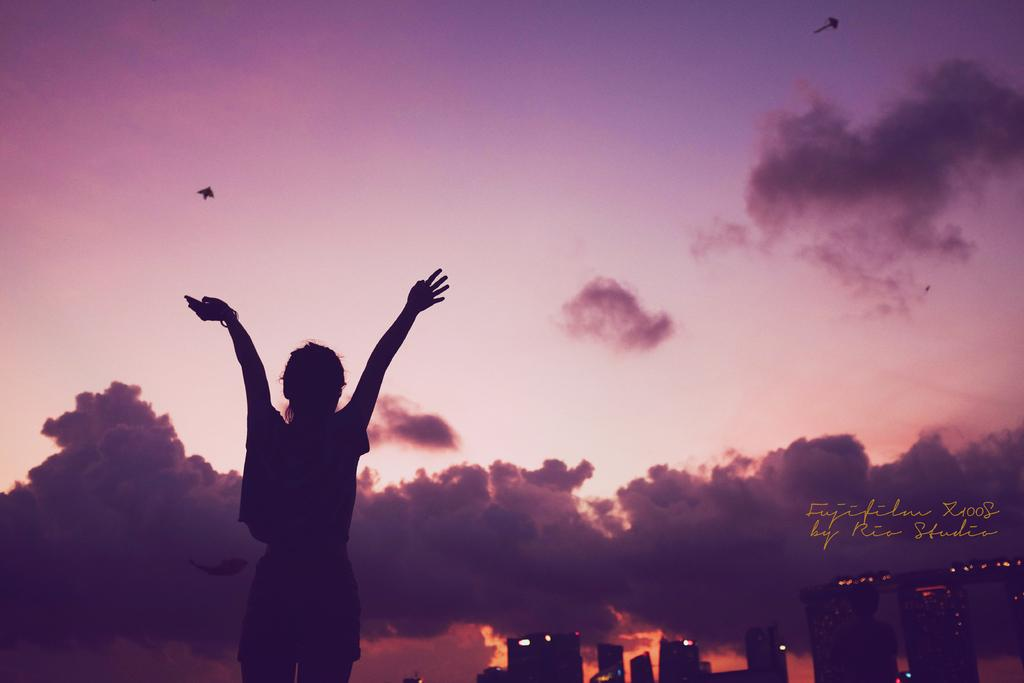What is the main subject of the image? There is a woman standing in the image. What else can be seen in the image besides the woman? There are buildings, lights, text, and birds flying in the sky in the image. What is the background of the image like? The background of the image includes a colorful, cloudy sky. What book is the woman reading in the image? There is no book present in the image, and the woman is not reading. Is there a fight happening between the woman and the birds in the image? No, there is no fight depicted in the image; the woman is standing and the birds are flying in the sky. 